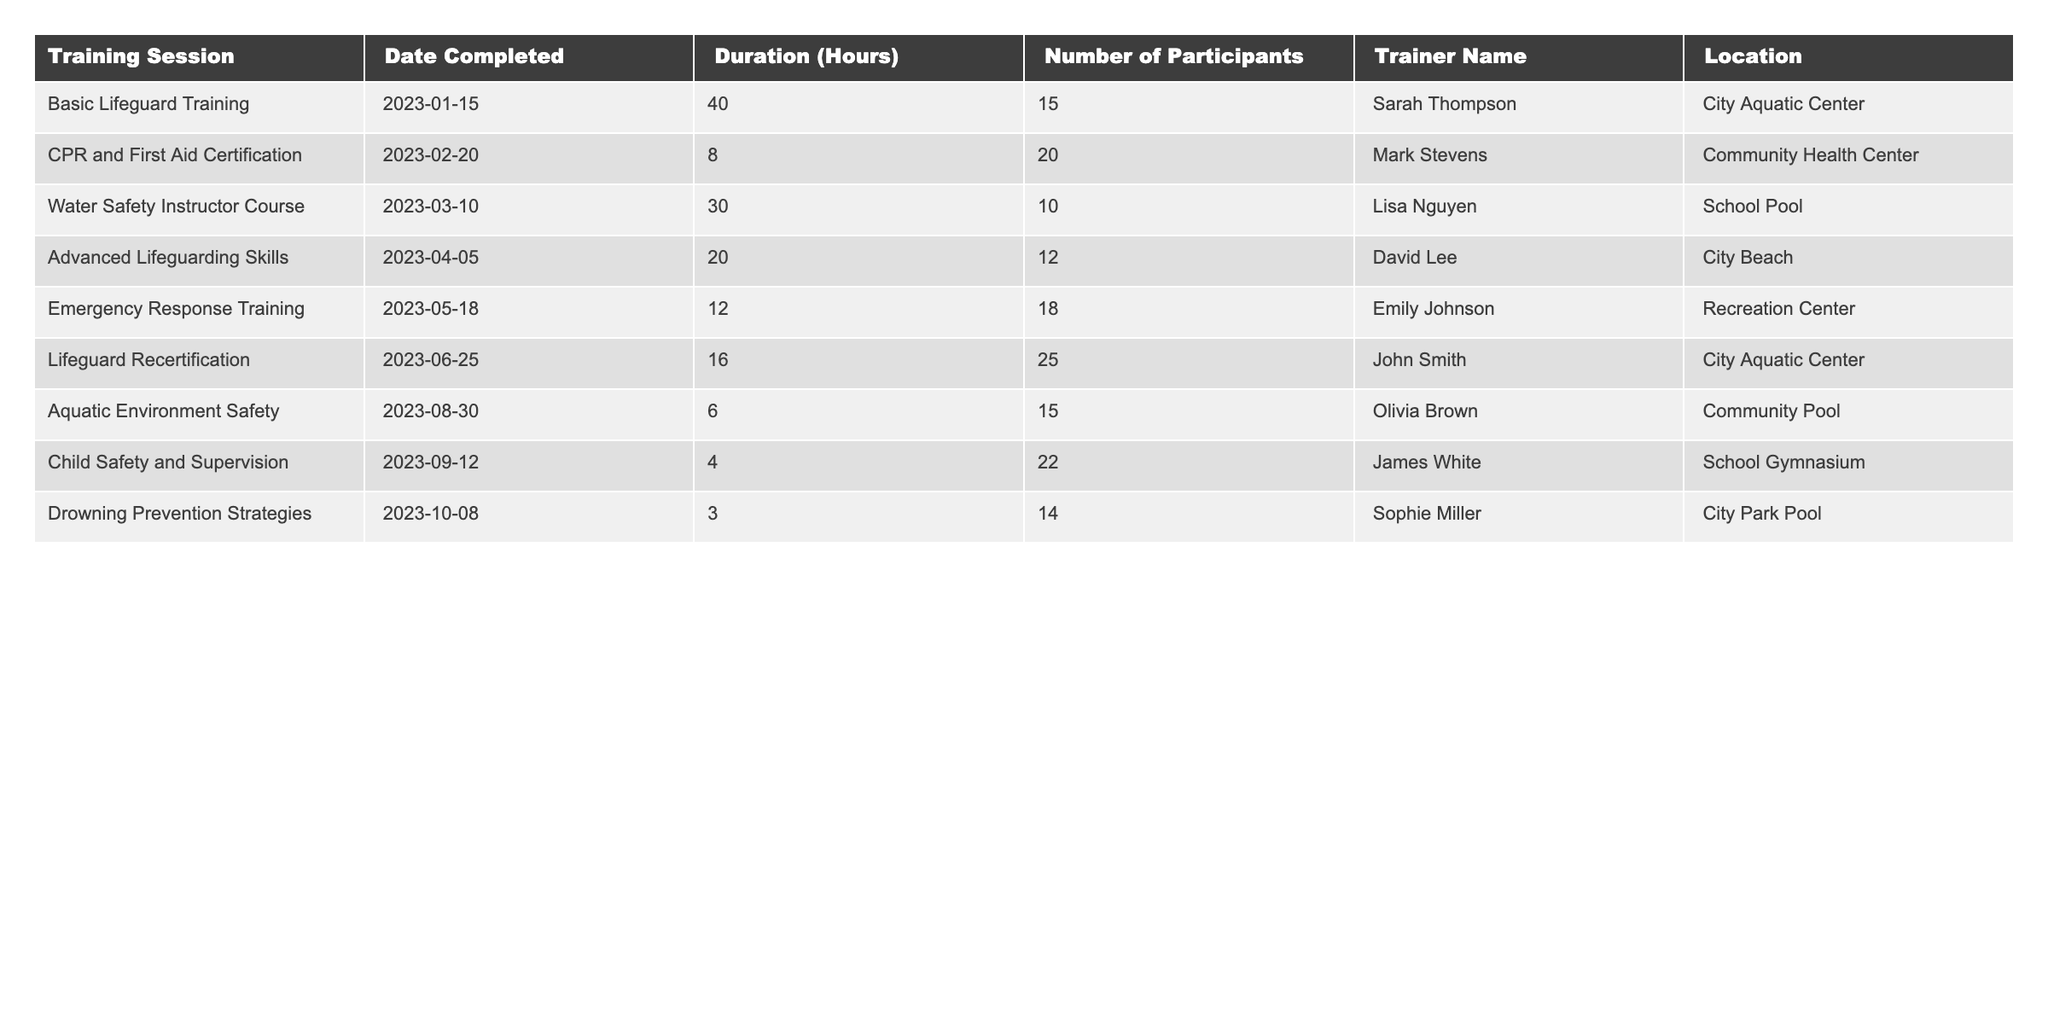What is the total number of participants who completed the Emergency Response Training? From the table, we see that 18 participants completed the Emergency Response Training session.
Answer: 18 Which training session had the longest duration and how long was it? The Basic Lifeguard Training session had the longest duration of 40 hours.
Answer: 40 hours How many training sessions were conducted at the City Aquatic Center? There are two training sessions listed at the City Aquatic Center: Basic Lifeguard Training and Lifeguard Recertification.
Answer: 2 What is the average duration of all training sessions listed in the table? The total duration of sessions is 40 + 8 + 30 + 20 + 12 + 16 + 6 + 4 + 3 = 139 hours. There are 9 sessions, so the average is 139 / 9 = approximately 15.44 hours.
Answer: 15.44 hours Which trainer conducted the most training sessions? Counting the entries, Sarah Thompson, Mark Stevens, and John Smith each conducted 2 sessions (Sarah for Basic Lifeguard Training and Lifeguard Recertification; Mark for CPR and First Aid Certification; John for Lifeguard Recertification).
Answer: 3 trainers conducted multiple sessions How many sessions focused specifically on child safety? The table shows one session, "Child Safety and Supervision," focused specifically on child safety.
Answer: 1 Is there a training session that took place after August 1, 2023? Yes, there are two sessions after August 1, 2023: "Child Safety and Supervision" on 2023-09-12 and "Drowning Prevention Strategies" on 2023-10-08.
Answer: Yes What is the total number of hours spent on all training sessions held in the Community Health Center? Referring to the table, the only session held at the Community Health Center was the CPR and First Aid Certification, which lasted 8 hours.
Answer: 8 hours Which location had the highest number of participants in a training session, and how many? The Lifeguard Recertification session at the City Aquatic Center had the highest number of participants, totaling 25.
Answer: City Aquatic Center, 25 participants Was the Water Safety Instructor Course attended by more participants than the Advanced Lifeguarding Skills training? The Water Safety Instructor Course had 10 participants, while the Advanced Lifeguarding Skills had 12, so more attended the Advanced Lifeguarding Skills.
Answer: No 